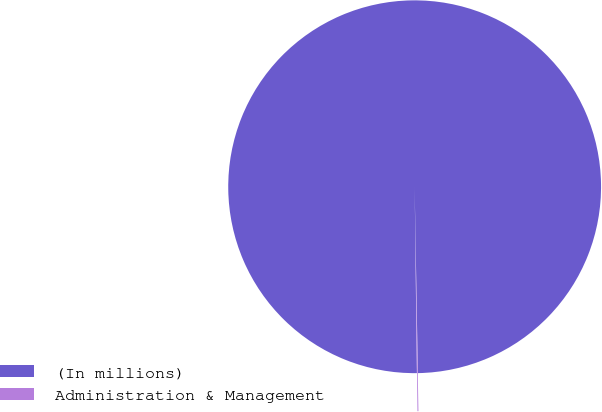Convert chart. <chart><loc_0><loc_0><loc_500><loc_500><pie_chart><fcel>(In millions)<fcel>Administration & Management<nl><fcel>99.92%<fcel>0.08%<nl></chart> 